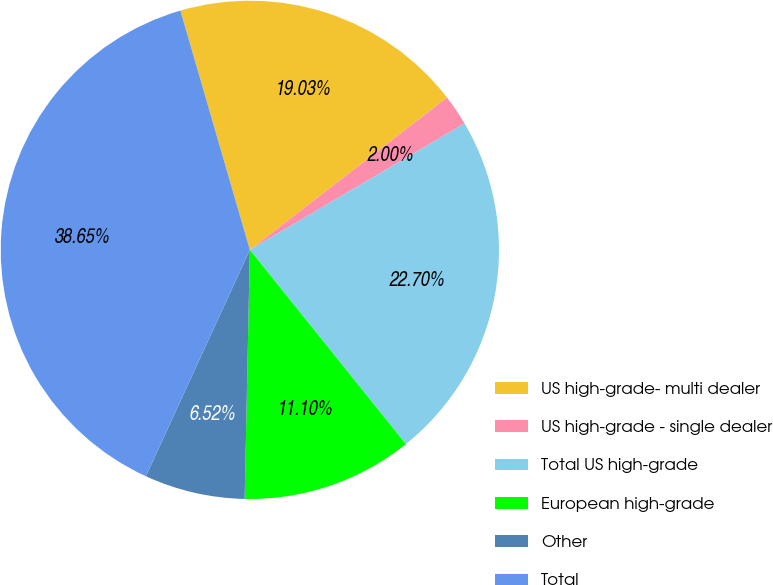Convert chart. <chart><loc_0><loc_0><loc_500><loc_500><pie_chart><fcel>US high-grade- multi dealer<fcel>US high-grade - single dealer<fcel>Total US high-grade<fcel>European high-grade<fcel>Other<fcel>Total<nl><fcel>19.03%<fcel>2.0%<fcel>22.7%<fcel>11.1%<fcel>6.52%<fcel>38.65%<nl></chart> 